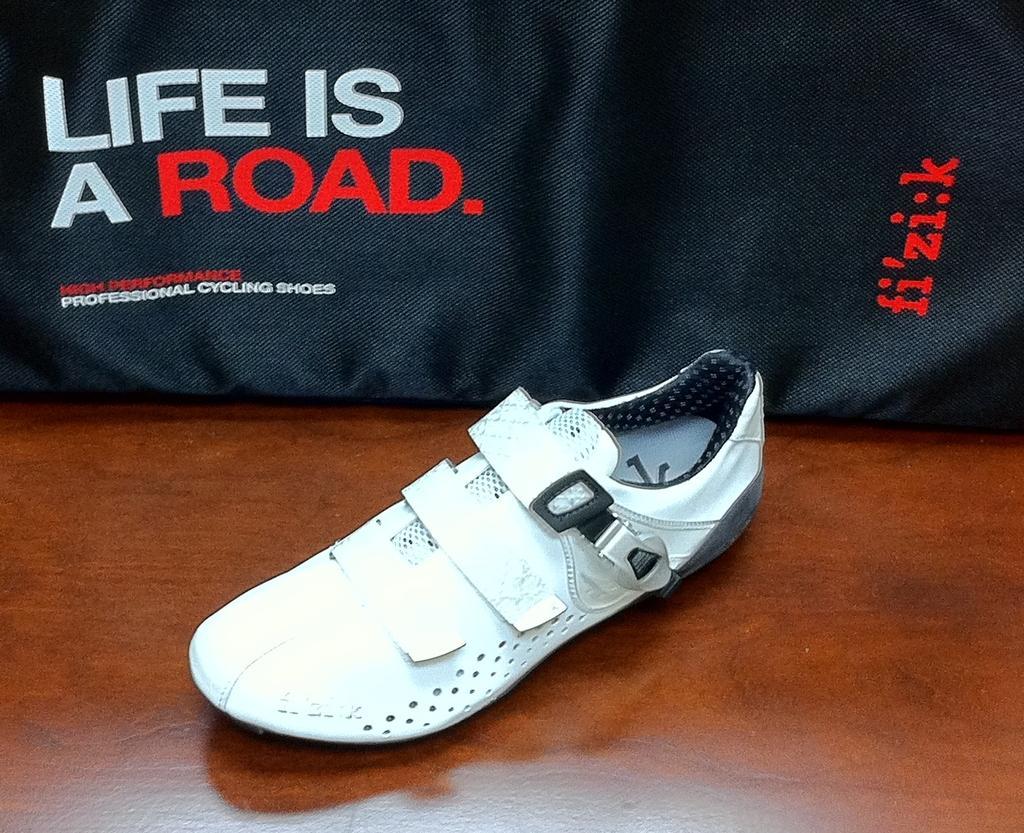Could you give a brief overview of what you see in this image? In the picture there is a white shoe and behind the shoe there is a black cloth and some quotation is written on that cloth. 